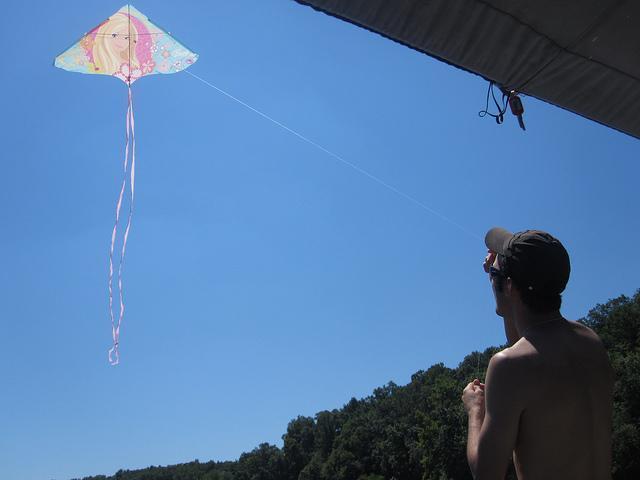How many kites are in the sky?
Give a very brief answer. 1. How many tails does this kite have?
Give a very brief answer. 2. How many giraffes are there?
Give a very brief answer. 0. 